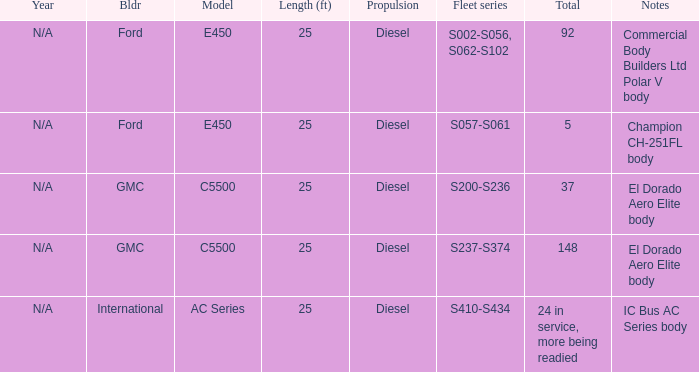Would you mind parsing the complete table? {'header': ['Year', 'Bldr', 'Model', 'Length (ft)', 'Propulsion', 'Fleet series', 'Total', 'Notes'], 'rows': [['N/A', 'Ford', 'E450', '25', 'Diesel', 'S002-S056, S062-S102', '92', 'Commercial Body Builders Ltd Polar V body'], ['N/A', 'Ford', 'E450', '25', 'Diesel', 'S057-S061', '5', 'Champion CH-251FL body'], ['N/A', 'GMC', 'C5500', '25', 'Diesel', 'S200-S236', '37', 'El Dorado Aero Elite body'], ['N/A', 'GMC', 'C5500', '25', 'Diesel', 'S237-S374', '148', 'El Dorado Aero Elite body'], ['N/A', 'International', 'AC Series', '25', 'Diesel', 'S410-S434', '24 in service, more being readied', 'IC Bus AC Series body']]} Which builder has a fleet series of s057-s061? Ford. 